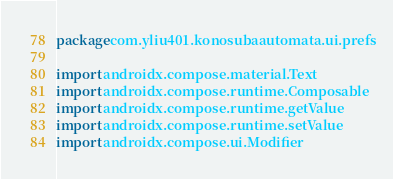<code> <loc_0><loc_0><loc_500><loc_500><_Kotlin_>package com.yliu401.konosubaautomata.ui.prefs

import androidx.compose.material.Text
import androidx.compose.runtime.Composable
import androidx.compose.runtime.getValue
import androidx.compose.runtime.setValue
import androidx.compose.ui.Modifier</code> 